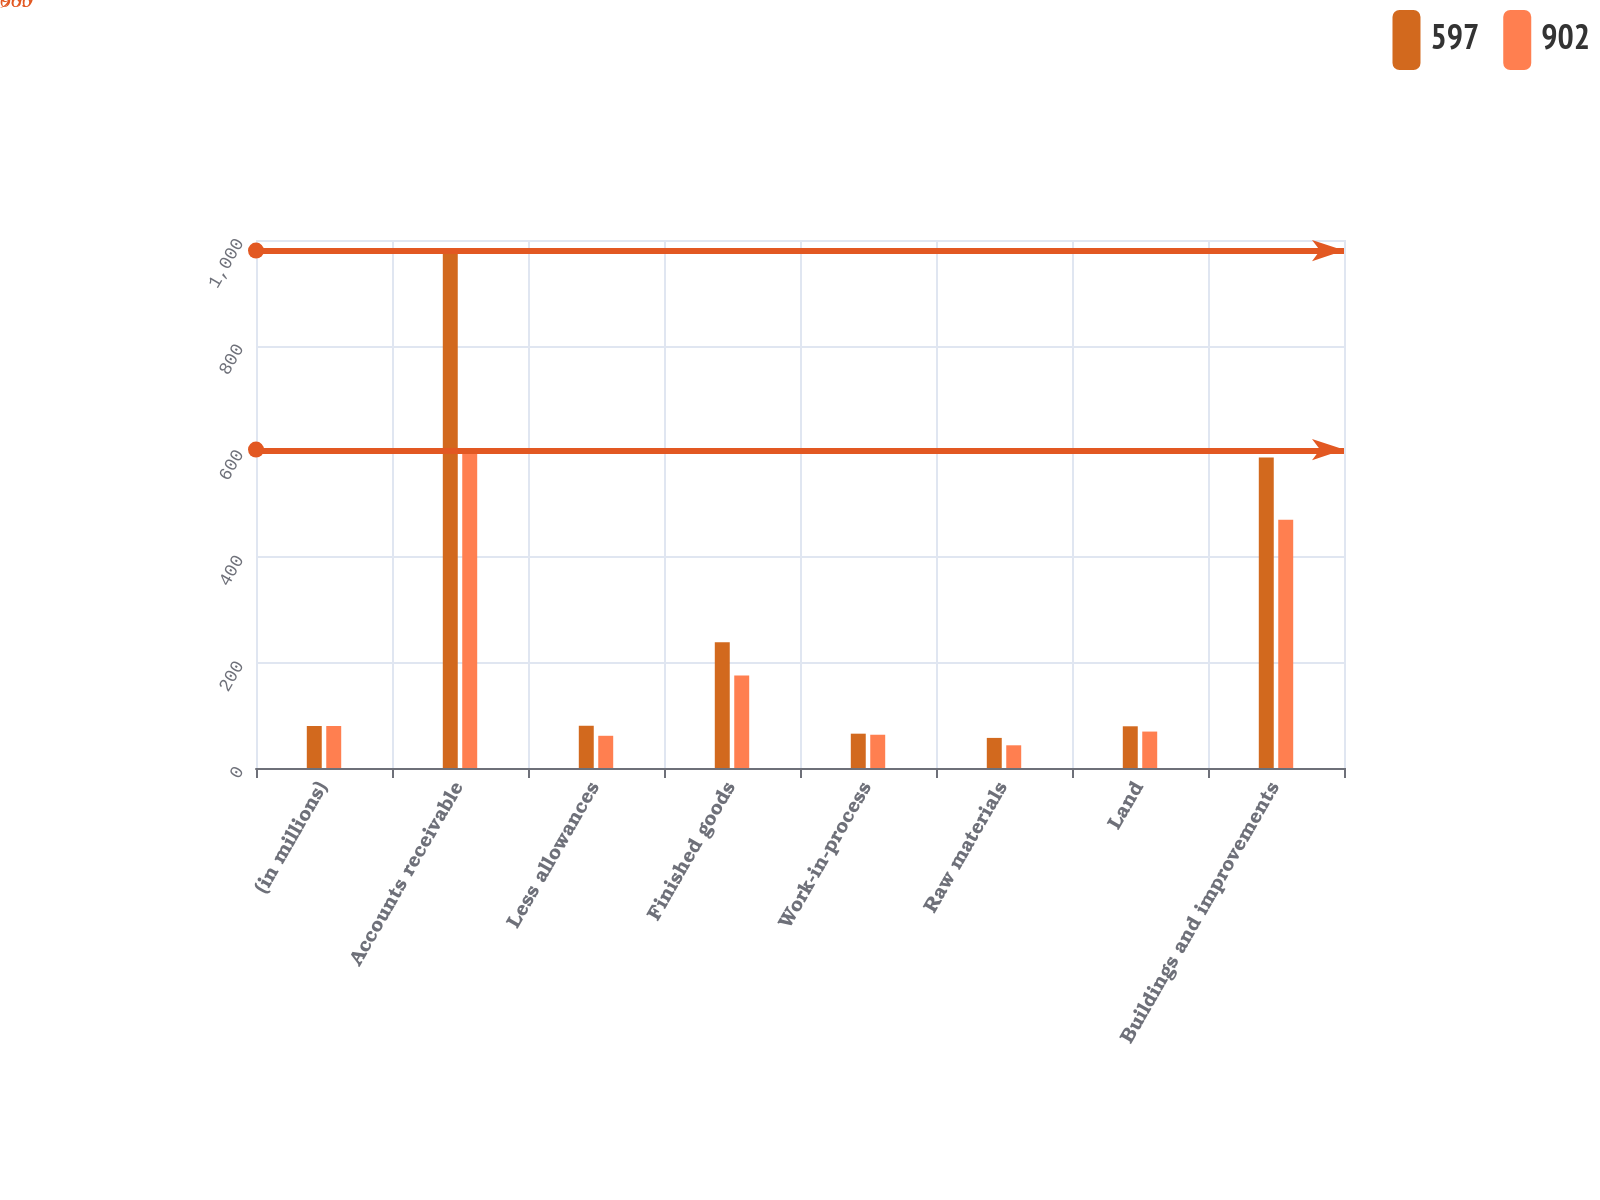Convert chart. <chart><loc_0><loc_0><loc_500><loc_500><stacked_bar_chart><ecel><fcel>(in millions)<fcel>Accounts receivable<fcel>Less allowances<fcel>Finished goods<fcel>Work-in-process<fcel>Raw materials<fcel>Land<fcel>Buildings and improvements<nl><fcel>597<fcel>79.5<fcel>980<fcel>80<fcel>238<fcel>65<fcel>57<fcel>79<fcel>588<nl><fcel>902<fcel>79.5<fcel>603<fcel>61<fcel>175<fcel>63<fcel>43<fcel>69<fcel>470<nl></chart> 